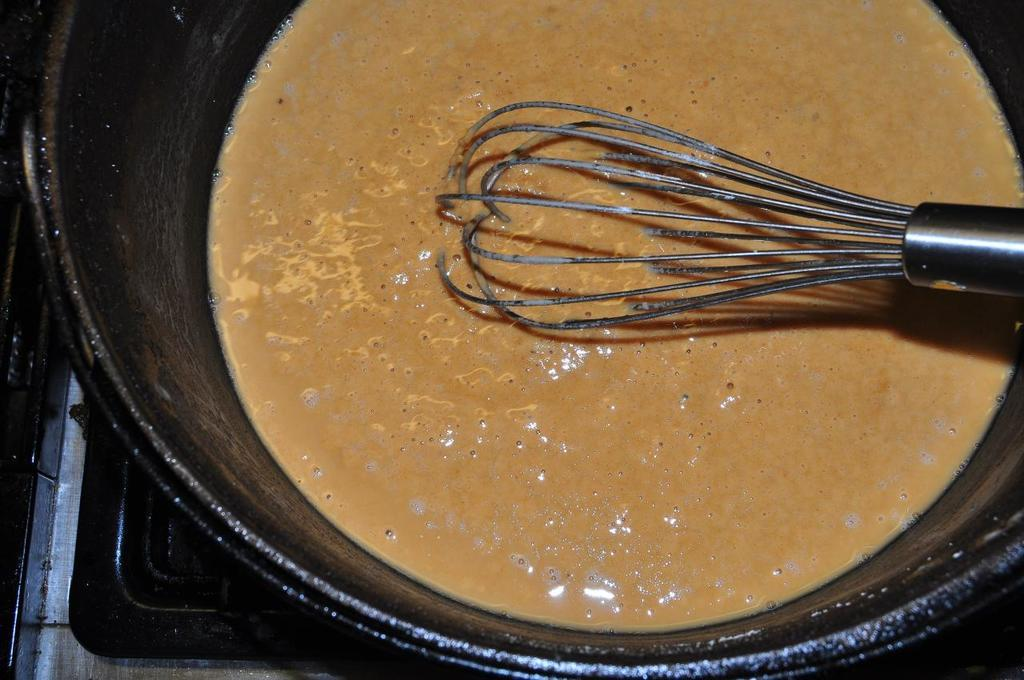What is in the image that can hold liquid? There is a bowl in the image that can hold liquid. What is inside the bowl? There is liquid in the bowl. What is used to mix or stir the liquid in the bowl? There is a stirrer in the image. What type of pail is used to carry the liquid in the image? There is no pail present in the image; it features a bowl with liquid and a stirrer. What are the things that people desire in the image? The image does not depict any desires or emotions; it only shows a bowl with liquid and a stirrer. 